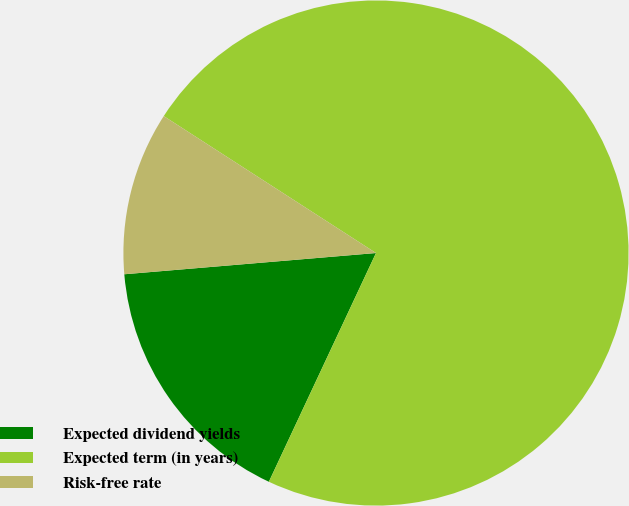<chart> <loc_0><loc_0><loc_500><loc_500><pie_chart><fcel>Expected dividend yields<fcel>Expected term (in years)<fcel>Risk-free rate<nl><fcel>16.69%<fcel>72.85%<fcel>10.46%<nl></chart> 